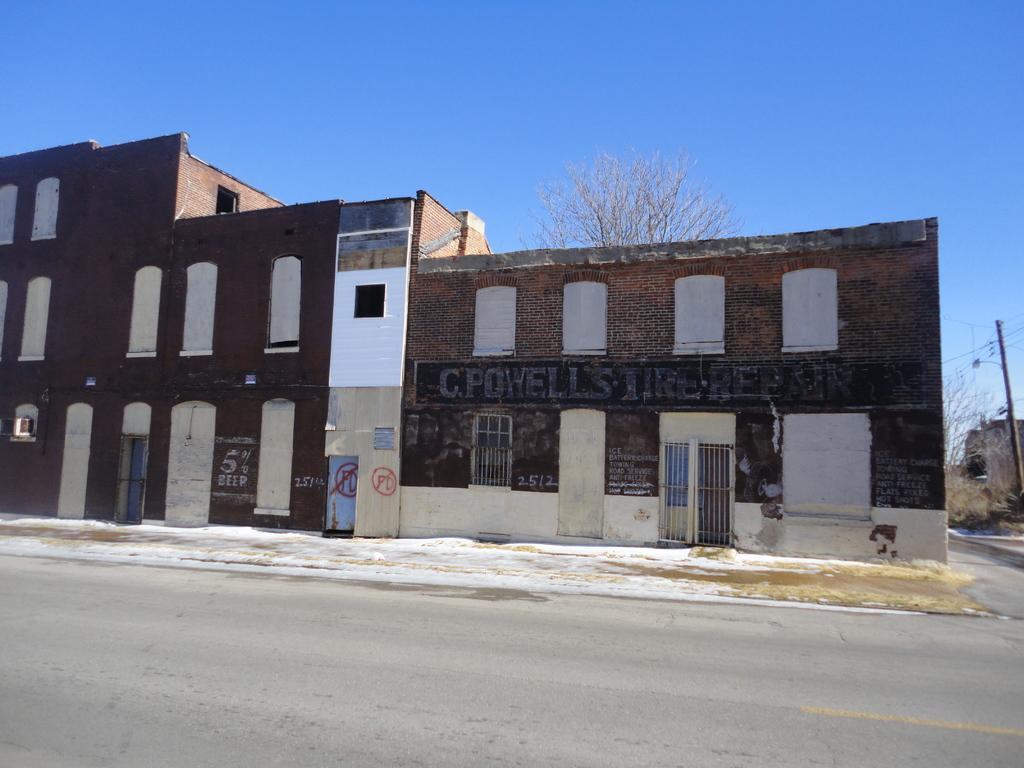What type of structures are present in the image? There are buildings in the image. What is located at the bottom of the image? There is a road at the bottom of the image. What can be seen on the right side of the image? There is a pole on the right side of the image. What is visible in the background of the image? There are trees and the sky in the background of the image. What time is displayed on the clocks in the image? There are no clocks present in the image. What type of friction is occurring between the buildings and the road in the image? There is no indication of friction between the buildings and the road in the image, as it is a static representation. 